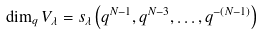<formula> <loc_0><loc_0><loc_500><loc_500>\dim _ { q } V _ { \lambda } = s _ { \lambda } \left ( q ^ { N - 1 } , q ^ { N - 3 } , \dots , q ^ { - ( N - 1 ) } \right )</formula> 